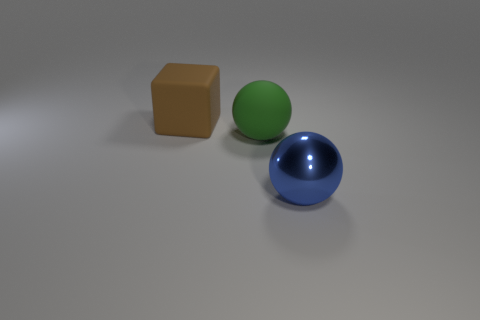Is the big blue object the same shape as the brown thing?
Offer a terse response. No. There is a large matte object that is on the right side of the big matte cube; is there a large blue thing in front of it?
Your answer should be compact. Yes. What is the shape of the rubber object on the right side of the large rubber block?
Provide a succinct answer. Sphere. There is a matte thing behind the sphere behind the large shiny thing; how many big things are on the right side of it?
Ensure brevity in your answer.  2. Is the size of the brown matte thing the same as the ball to the left of the blue ball?
Make the answer very short. Yes. There is a rubber thing to the left of the ball that is on the left side of the blue metal sphere; how big is it?
Your response must be concise. Large. What number of other big things have the same material as the large brown thing?
Keep it short and to the point. 1. Is there a large sphere?
Give a very brief answer. Yes. How many rubber spheres have the same color as the shiny object?
Provide a short and direct response. 0. How many blocks are either large blue objects or large red matte objects?
Make the answer very short. 0. 